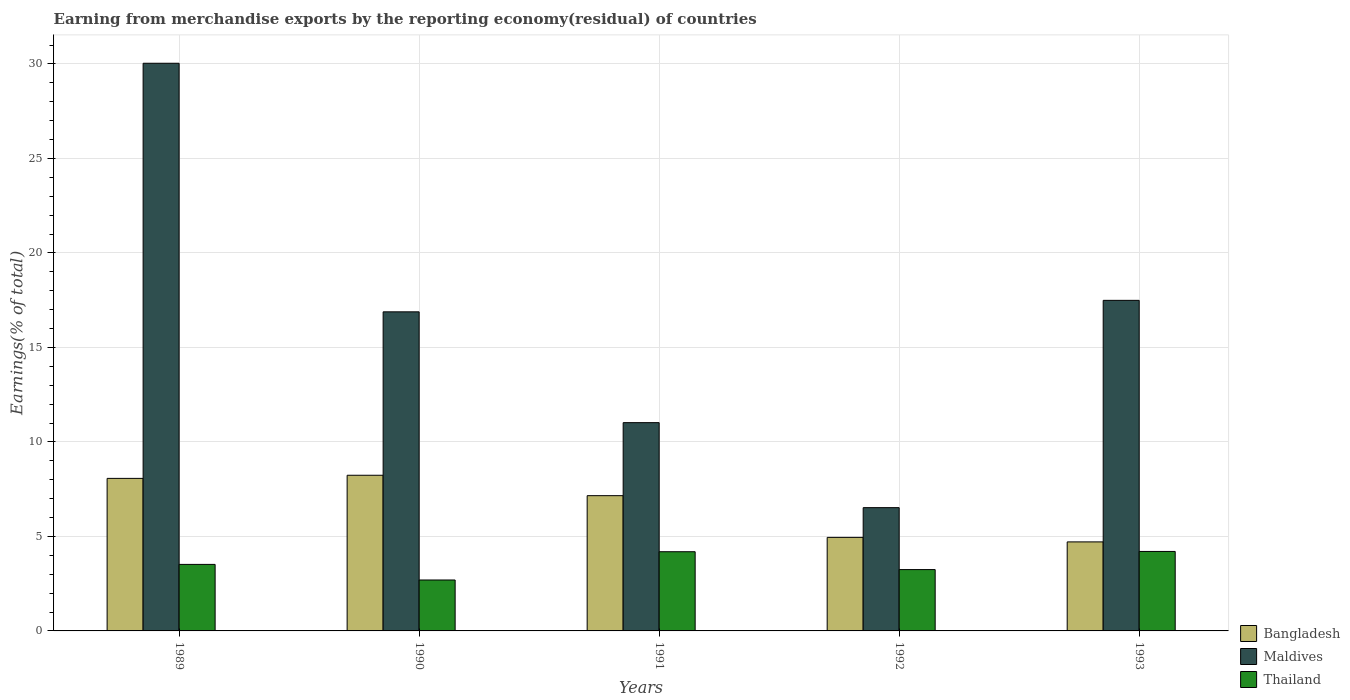How many groups of bars are there?
Offer a very short reply. 5. Are the number of bars per tick equal to the number of legend labels?
Give a very brief answer. Yes. How many bars are there on the 1st tick from the left?
Offer a very short reply. 3. In how many cases, is the number of bars for a given year not equal to the number of legend labels?
Provide a short and direct response. 0. What is the percentage of amount earned from merchandise exports in Thailand in 1990?
Offer a very short reply. 2.69. Across all years, what is the maximum percentage of amount earned from merchandise exports in Thailand?
Keep it short and to the point. 4.21. Across all years, what is the minimum percentage of amount earned from merchandise exports in Bangladesh?
Offer a terse response. 4.71. In which year was the percentage of amount earned from merchandise exports in Bangladesh maximum?
Offer a terse response. 1990. What is the total percentage of amount earned from merchandise exports in Thailand in the graph?
Your response must be concise. 17.86. What is the difference between the percentage of amount earned from merchandise exports in Thailand in 1989 and that in 1991?
Your response must be concise. -0.67. What is the difference between the percentage of amount earned from merchandise exports in Thailand in 1993 and the percentage of amount earned from merchandise exports in Maldives in 1989?
Your response must be concise. -25.83. What is the average percentage of amount earned from merchandise exports in Bangladesh per year?
Ensure brevity in your answer.  6.62. In the year 1991, what is the difference between the percentage of amount earned from merchandise exports in Bangladesh and percentage of amount earned from merchandise exports in Maldives?
Provide a succinct answer. -3.86. In how many years, is the percentage of amount earned from merchandise exports in Bangladesh greater than 22 %?
Offer a terse response. 0. What is the ratio of the percentage of amount earned from merchandise exports in Thailand in 1991 to that in 1992?
Offer a terse response. 1.29. What is the difference between the highest and the second highest percentage of amount earned from merchandise exports in Maldives?
Provide a short and direct response. 12.54. What is the difference between the highest and the lowest percentage of amount earned from merchandise exports in Bangladesh?
Make the answer very short. 3.53. What does the 1st bar from the left in 1989 represents?
Offer a terse response. Bangladesh. What does the 1st bar from the right in 1993 represents?
Ensure brevity in your answer.  Thailand. Are all the bars in the graph horizontal?
Offer a very short reply. No. How many years are there in the graph?
Offer a very short reply. 5. What is the difference between two consecutive major ticks on the Y-axis?
Keep it short and to the point. 5. Does the graph contain grids?
Your answer should be compact. Yes. Where does the legend appear in the graph?
Keep it short and to the point. Bottom right. What is the title of the graph?
Provide a short and direct response. Earning from merchandise exports by the reporting economy(residual) of countries. Does "Pakistan" appear as one of the legend labels in the graph?
Your response must be concise. No. What is the label or title of the X-axis?
Your response must be concise. Years. What is the label or title of the Y-axis?
Your answer should be very brief. Earnings(% of total). What is the Earnings(% of total) of Bangladesh in 1989?
Make the answer very short. 8.07. What is the Earnings(% of total) in Maldives in 1989?
Your answer should be compact. 30.04. What is the Earnings(% of total) of Thailand in 1989?
Provide a succinct answer. 3.52. What is the Earnings(% of total) in Bangladesh in 1990?
Your answer should be compact. 8.24. What is the Earnings(% of total) of Maldives in 1990?
Make the answer very short. 16.88. What is the Earnings(% of total) in Thailand in 1990?
Give a very brief answer. 2.69. What is the Earnings(% of total) in Bangladesh in 1991?
Ensure brevity in your answer.  7.16. What is the Earnings(% of total) of Maldives in 1991?
Provide a succinct answer. 11.02. What is the Earnings(% of total) in Thailand in 1991?
Your response must be concise. 4.19. What is the Earnings(% of total) of Bangladesh in 1992?
Provide a short and direct response. 4.95. What is the Earnings(% of total) in Maldives in 1992?
Your response must be concise. 6.52. What is the Earnings(% of total) of Thailand in 1992?
Offer a very short reply. 3.25. What is the Earnings(% of total) in Bangladesh in 1993?
Your answer should be compact. 4.71. What is the Earnings(% of total) of Maldives in 1993?
Offer a terse response. 17.49. What is the Earnings(% of total) of Thailand in 1993?
Give a very brief answer. 4.21. Across all years, what is the maximum Earnings(% of total) of Bangladesh?
Provide a short and direct response. 8.24. Across all years, what is the maximum Earnings(% of total) in Maldives?
Your answer should be compact. 30.04. Across all years, what is the maximum Earnings(% of total) in Thailand?
Offer a very short reply. 4.21. Across all years, what is the minimum Earnings(% of total) in Bangladesh?
Your answer should be compact. 4.71. Across all years, what is the minimum Earnings(% of total) of Maldives?
Provide a succinct answer. 6.52. Across all years, what is the minimum Earnings(% of total) in Thailand?
Give a very brief answer. 2.69. What is the total Earnings(% of total) in Bangladesh in the graph?
Provide a succinct answer. 33.12. What is the total Earnings(% of total) of Maldives in the graph?
Your response must be concise. 81.95. What is the total Earnings(% of total) in Thailand in the graph?
Offer a very short reply. 17.86. What is the difference between the Earnings(% of total) of Bangladesh in 1989 and that in 1990?
Provide a succinct answer. -0.17. What is the difference between the Earnings(% of total) of Maldives in 1989 and that in 1990?
Your answer should be compact. 13.15. What is the difference between the Earnings(% of total) in Thailand in 1989 and that in 1990?
Offer a very short reply. 0.83. What is the difference between the Earnings(% of total) of Bangladesh in 1989 and that in 1991?
Offer a very short reply. 0.91. What is the difference between the Earnings(% of total) in Maldives in 1989 and that in 1991?
Your response must be concise. 19.02. What is the difference between the Earnings(% of total) of Thailand in 1989 and that in 1991?
Keep it short and to the point. -0.67. What is the difference between the Earnings(% of total) in Bangladesh in 1989 and that in 1992?
Provide a succinct answer. 3.12. What is the difference between the Earnings(% of total) of Maldives in 1989 and that in 1992?
Provide a succinct answer. 23.51. What is the difference between the Earnings(% of total) of Thailand in 1989 and that in 1992?
Your response must be concise. 0.27. What is the difference between the Earnings(% of total) in Bangladesh in 1989 and that in 1993?
Provide a short and direct response. 3.36. What is the difference between the Earnings(% of total) of Maldives in 1989 and that in 1993?
Make the answer very short. 12.54. What is the difference between the Earnings(% of total) of Thailand in 1989 and that in 1993?
Provide a short and direct response. -0.69. What is the difference between the Earnings(% of total) in Bangladesh in 1990 and that in 1991?
Your response must be concise. 1.08. What is the difference between the Earnings(% of total) in Maldives in 1990 and that in 1991?
Provide a short and direct response. 5.86. What is the difference between the Earnings(% of total) in Thailand in 1990 and that in 1991?
Your response must be concise. -1.5. What is the difference between the Earnings(% of total) in Bangladesh in 1990 and that in 1992?
Your answer should be compact. 3.29. What is the difference between the Earnings(% of total) of Maldives in 1990 and that in 1992?
Your response must be concise. 10.36. What is the difference between the Earnings(% of total) of Thailand in 1990 and that in 1992?
Your response must be concise. -0.55. What is the difference between the Earnings(% of total) in Bangladesh in 1990 and that in 1993?
Your answer should be very brief. 3.53. What is the difference between the Earnings(% of total) in Maldives in 1990 and that in 1993?
Offer a terse response. -0.61. What is the difference between the Earnings(% of total) of Thailand in 1990 and that in 1993?
Your answer should be compact. -1.51. What is the difference between the Earnings(% of total) in Bangladesh in 1991 and that in 1992?
Your response must be concise. 2.21. What is the difference between the Earnings(% of total) in Maldives in 1991 and that in 1992?
Offer a terse response. 4.5. What is the difference between the Earnings(% of total) in Thailand in 1991 and that in 1992?
Your answer should be very brief. 0.94. What is the difference between the Earnings(% of total) in Bangladesh in 1991 and that in 1993?
Give a very brief answer. 2.45. What is the difference between the Earnings(% of total) of Maldives in 1991 and that in 1993?
Offer a terse response. -6.47. What is the difference between the Earnings(% of total) of Thailand in 1991 and that in 1993?
Your answer should be very brief. -0.02. What is the difference between the Earnings(% of total) of Bangladesh in 1992 and that in 1993?
Your answer should be compact. 0.24. What is the difference between the Earnings(% of total) in Maldives in 1992 and that in 1993?
Offer a very short reply. -10.97. What is the difference between the Earnings(% of total) in Thailand in 1992 and that in 1993?
Offer a terse response. -0.96. What is the difference between the Earnings(% of total) in Bangladesh in 1989 and the Earnings(% of total) in Maldives in 1990?
Provide a short and direct response. -8.81. What is the difference between the Earnings(% of total) of Bangladesh in 1989 and the Earnings(% of total) of Thailand in 1990?
Ensure brevity in your answer.  5.38. What is the difference between the Earnings(% of total) of Maldives in 1989 and the Earnings(% of total) of Thailand in 1990?
Offer a very short reply. 27.34. What is the difference between the Earnings(% of total) of Bangladesh in 1989 and the Earnings(% of total) of Maldives in 1991?
Keep it short and to the point. -2.95. What is the difference between the Earnings(% of total) of Bangladesh in 1989 and the Earnings(% of total) of Thailand in 1991?
Give a very brief answer. 3.88. What is the difference between the Earnings(% of total) of Maldives in 1989 and the Earnings(% of total) of Thailand in 1991?
Offer a terse response. 25.85. What is the difference between the Earnings(% of total) of Bangladesh in 1989 and the Earnings(% of total) of Maldives in 1992?
Your response must be concise. 1.55. What is the difference between the Earnings(% of total) of Bangladesh in 1989 and the Earnings(% of total) of Thailand in 1992?
Give a very brief answer. 4.83. What is the difference between the Earnings(% of total) in Maldives in 1989 and the Earnings(% of total) in Thailand in 1992?
Provide a short and direct response. 26.79. What is the difference between the Earnings(% of total) of Bangladesh in 1989 and the Earnings(% of total) of Maldives in 1993?
Your answer should be compact. -9.42. What is the difference between the Earnings(% of total) of Bangladesh in 1989 and the Earnings(% of total) of Thailand in 1993?
Provide a succinct answer. 3.87. What is the difference between the Earnings(% of total) in Maldives in 1989 and the Earnings(% of total) in Thailand in 1993?
Offer a very short reply. 25.83. What is the difference between the Earnings(% of total) of Bangladesh in 1990 and the Earnings(% of total) of Maldives in 1991?
Ensure brevity in your answer.  -2.78. What is the difference between the Earnings(% of total) of Bangladesh in 1990 and the Earnings(% of total) of Thailand in 1991?
Your answer should be very brief. 4.05. What is the difference between the Earnings(% of total) in Maldives in 1990 and the Earnings(% of total) in Thailand in 1991?
Offer a terse response. 12.69. What is the difference between the Earnings(% of total) of Bangladesh in 1990 and the Earnings(% of total) of Maldives in 1992?
Keep it short and to the point. 1.71. What is the difference between the Earnings(% of total) in Bangladesh in 1990 and the Earnings(% of total) in Thailand in 1992?
Give a very brief answer. 4.99. What is the difference between the Earnings(% of total) in Maldives in 1990 and the Earnings(% of total) in Thailand in 1992?
Provide a succinct answer. 13.64. What is the difference between the Earnings(% of total) in Bangladesh in 1990 and the Earnings(% of total) in Maldives in 1993?
Give a very brief answer. -9.25. What is the difference between the Earnings(% of total) of Bangladesh in 1990 and the Earnings(% of total) of Thailand in 1993?
Ensure brevity in your answer.  4.03. What is the difference between the Earnings(% of total) of Maldives in 1990 and the Earnings(% of total) of Thailand in 1993?
Give a very brief answer. 12.68. What is the difference between the Earnings(% of total) in Bangladesh in 1991 and the Earnings(% of total) in Maldives in 1992?
Give a very brief answer. 0.63. What is the difference between the Earnings(% of total) of Bangladesh in 1991 and the Earnings(% of total) of Thailand in 1992?
Your response must be concise. 3.91. What is the difference between the Earnings(% of total) in Maldives in 1991 and the Earnings(% of total) in Thailand in 1992?
Keep it short and to the point. 7.77. What is the difference between the Earnings(% of total) in Bangladesh in 1991 and the Earnings(% of total) in Maldives in 1993?
Provide a succinct answer. -10.33. What is the difference between the Earnings(% of total) in Bangladesh in 1991 and the Earnings(% of total) in Thailand in 1993?
Make the answer very short. 2.95. What is the difference between the Earnings(% of total) of Maldives in 1991 and the Earnings(% of total) of Thailand in 1993?
Make the answer very short. 6.81. What is the difference between the Earnings(% of total) of Bangladesh in 1992 and the Earnings(% of total) of Maldives in 1993?
Your answer should be compact. -12.54. What is the difference between the Earnings(% of total) of Bangladesh in 1992 and the Earnings(% of total) of Thailand in 1993?
Your answer should be compact. 0.74. What is the difference between the Earnings(% of total) of Maldives in 1992 and the Earnings(% of total) of Thailand in 1993?
Ensure brevity in your answer.  2.32. What is the average Earnings(% of total) in Bangladesh per year?
Offer a very short reply. 6.62. What is the average Earnings(% of total) in Maldives per year?
Make the answer very short. 16.39. What is the average Earnings(% of total) in Thailand per year?
Your answer should be compact. 3.57. In the year 1989, what is the difference between the Earnings(% of total) in Bangladesh and Earnings(% of total) in Maldives?
Offer a terse response. -21.96. In the year 1989, what is the difference between the Earnings(% of total) in Bangladesh and Earnings(% of total) in Thailand?
Keep it short and to the point. 4.55. In the year 1989, what is the difference between the Earnings(% of total) in Maldives and Earnings(% of total) in Thailand?
Provide a short and direct response. 26.52. In the year 1990, what is the difference between the Earnings(% of total) in Bangladesh and Earnings(% of total) in Maldives?
Ensure brevity in your answer.  -8.65. In the year 1990, what is the difference between the Earnings(% of total) of Bangladesh and Earnings(% of total) of Thailand?
Your answer should be very brief. 5.54. In the year 1990, what is the difference between the Earnings(% of total) of Maldives and Earnings(% of total) of Thailand?
Offer a terse response. 14.19. In the year 1991, what is the difference between the Earnings(% of total) of Bangladesh and Earnings(% of total) of Maldives?
Provide a short and direct response. -3.86. In the year 1991, what is the difference between the Earnings(% of total) of Bangladesh and Earnings(% of total) of Thailand?
Offer a very short reply. 2.97. In the year 1991, what is the difference between the Earnings(% of total) in Maldives and Earnings(% of total) in Thailand?
Your answer should be very brief. 6.83. In the year 1992, what is the difference between the Earnings(% of total) of Bangladesh and Earnings(% of total) of Maldives?
Offer a terse response. -1.57. In the year 1992, what is the difference between the Earnings(% of total) of Bangladesh and Earnings(% of total) of Thailand?
Ensure brevity in your answer.  1.7. In the year 1992, what is the difference between the Earnings(% of total) in Maldives and Earnings(% of total) in Thailand?
Keep it short and to the point. 3.28. In the year 1993, what is the difference between the Earnings(% of total) of Bangladesh and Earnings(% of total) of Maldives?
Ensure brevity in your answer.  -12.78. In the year 1993, what is the difference between the Earnings(% of total) in Bangladesh and Earnings(% of total) in Thailand?
Give a very brief answer. 0.51. In the year 1993, what is the difference between the Earnings(% of total) of Maldives and Earnings(% of total) of Thailand?
Give a very brief answer. 13.29. What is the ratio of the Earnings(% of total) of Bangladesh in 1989 to that in 1990?
Keep it short and to the point. 0.98. What is the ratio of the Earnings(% of total) of Maldives in 1989 to that in 1990?
Offer a terse response. 1.78. What is the ratio of the Earnings(% of total) of Thailand in 1989 to that in 1990?
Provide a succinct answer. 1.31. What is the ratio of the Earnings(% of total) in Bangladesh in 1989 to that in 1991?
Your response must be concise. 1.13. What is the ratio of the Earnings(% of total) of Maldives in 1989 to that in 1991?
Offer a very short reply. 2.73. What is the ratio of the Earnings(% of total) in Thailand in 1989 to that in 1991?
Provide a short and direct response. 0.84. What is the ratio of the Earnings(% of total) of Bangladesh in 1989 to that in 1992?
Provide a short and direct response. 1.63. What is the ratio of the Earnings(% of total) in Maldives in 1989 to that in 1992?
Offer a very short reply. 4.61. What is the ratio of the Earnings(% of total) of Thailand in 1989 to that in 1992?
Provide a short and direct response. 1.08. What is the ratio of the Earnings(% of total) of Bangladesh in 1989 to that in 1993?
Give a very brief answer. 1.71. What is the ratio of the Earnings(% of total) in Maldives in 1989 to that in 1993?
Offer a very short reply. 1.72. What is the ratio of the Earnings(% of total) of Thailand in 1989 to that in 1993?
Your answer should be compact. 0.84. What is the ratio of the Earnings(% of total) in Bangladesh in 1990 to that in 1991?
Give a very brief answer. 1.15. What is the ratio of the Earnings(% of total) in Maldives in 1990 to that in 1991?
Keep it short and to the point. 1.53. What is the ratio of the Earnings(% of total) in Thailand in 1990 to that in 1991?
Offer a very short reply. 0.64. What is the ratio of the Earnings(% of total) in Bangladesh in 1990 to that in 1992?
Provide a succinct answer. 1.66. What is the ratio of the Earnings(% of total) of Maldives in 1990 to that in 1992?
Give a very brief answer. 2.59. What is the ratio of the Earnings(% of total) in Thailand in 1990 to that in 1992?
Provide a short and direct response. 0.83. What is the ratio of the Earnings(% of total) in Bangladesh in 1990 to that in 1993?
Keep it short and to the point. 1.75. What is the ratio of the Earnings(% of total) in Maldives in 1990 to that in 1993?
Your answer should be compact. 0.97. What is the ratio of the Earnings(% of total) of Thailand in 1990 to that in 1993?
Keep it short and to the point. 0.64. What is the ratio of the Earnings(% of total) of Bangladesh in 1991 to that in 1992?
Provide a short and direct response. 1.45. What is the ratio of the Earnings(% of total) in Maldives in 1991 to that in 1992?
Keep it short and to the point. 1.69. What is the ratio of the Earnings(% of total) in Thailand in 1991 to that in 1992?
Offer a very short reply. 1.29. What is the ratio of the Earnings(% of total) of Bangladesh in 1991 to that in 1993?
Your answer should be compact. 1.52. What is the ratio of the Earnings(% of total) of Maldives in 1991 to that in 1993?
Provide a short and direct response. 0.63. What is the ratio of the Earnings(% of total) of Thailand in 1991 to that in 1993?
Keep it short and to the point. 1. What is the ratio of the Earnings(% of total) in Bangladesh in 1992 to that in 1993?
Your answer should be very brief. 1.05. What is the ratio of the Earnings(% of total) in Maldives in 1992 to that in 1993?
Your answer should be compact. 0.37. What is the ratio of the Earnings(% of total) in Thailand in 1992 to that in 1993?
Offer a very short reply. 0.77. What is the difference between the highest and the second highest Earnings(% of total) in Bangladesh?
Offer a terse response. 0.17. What is the difference between the highest and the second highest Earnings(% of total) of Maldives?
Make the answer very short. 12.54. What is the difference between the highest and the second highest Earnings(% of total) of Thailand?
Keep it short and to the point. 0.02. What is the difference between the highest and the lowest Earnings(% of total) in Bangladesh?
Offer a very short reply. 3.53. What is the difference between the highest and the lowest Earnings(% of total) in Maldives?
Keep it short and to the point. 23.51. What is the difference between the highest and the lowest Earnings(% of total) in Thailand?
Your answer should be very brief. 1.51. 